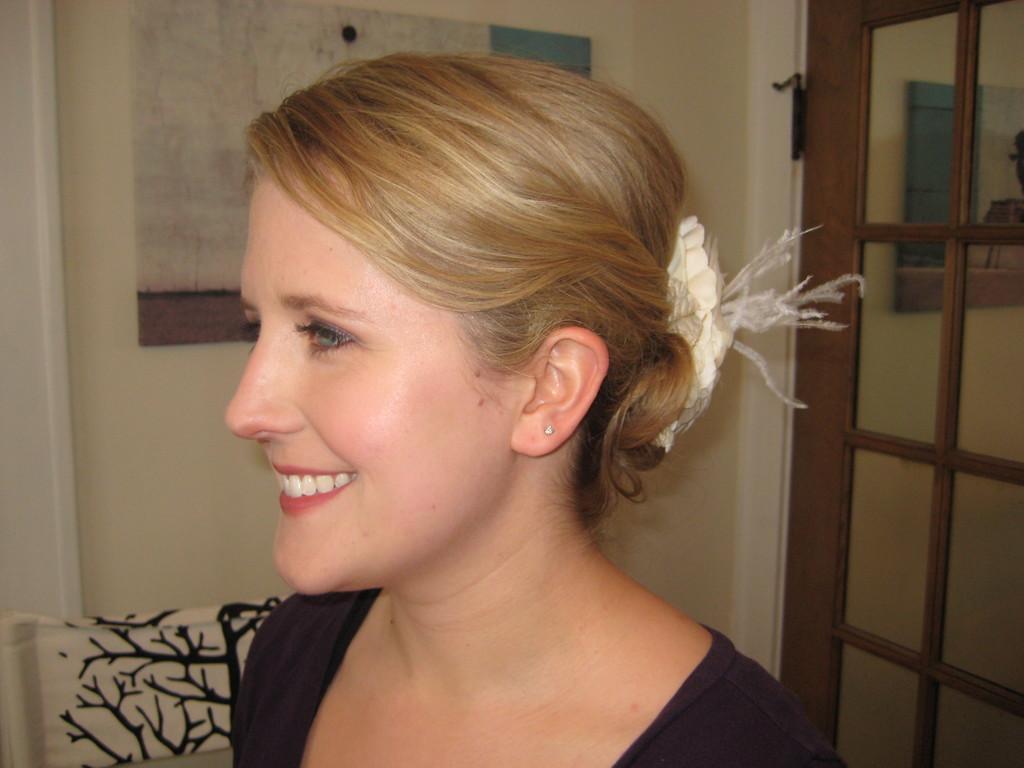Can you describe this image briefly? This is an inside view of a room. Here I can see a woman facing towards the left side and smiling. On the right side there is a door. In the background a board is attached to the wall. 